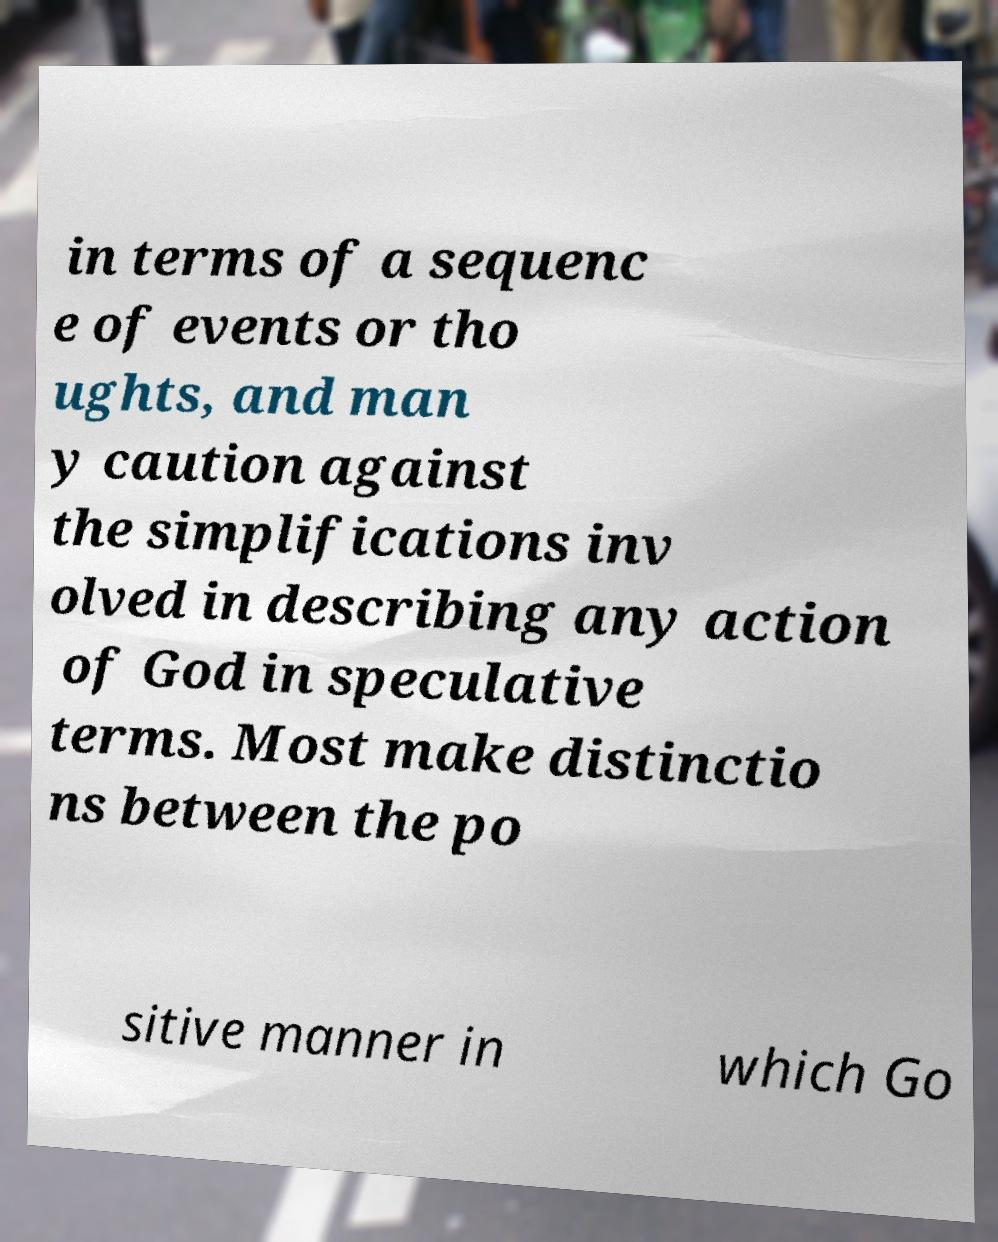Can you accurately transcribe the text from the provided image for me? in terms of a sequenc e of events or tho ughts, and man y caution against the simplifications inv olved in describing any action of God in speculative terms. Most make distinctio ns between the po sitive manner in which Go 